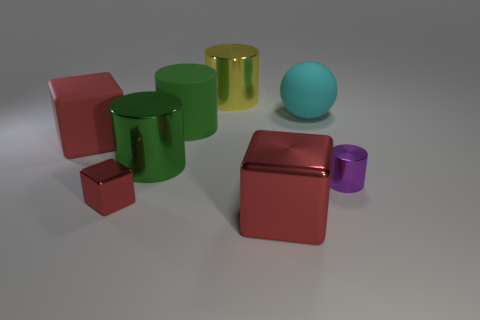Do the red object on the right side of the yellow metallic object and the big red rubber thing have the same shape?
Your answer should be very brief. Yes. Does the purple metal object have the same shape as the cyan object?
Provide a succinct answer. No. Is there another small red object that has the same shape as the red rubber object?
Offer a very short reply. Yes. The large green object behind the block that is behind the small metallic cylinder is what shape?
Ensure brevity in your answer.  Cylinder. There is a tiny thing on the left side of the large cyan sphere; what color is it?
Your response must be concise. Red. The purple cylinder that is the same material as the big yellow cylinder is what size?
Offer a terse response. Small. What size is the purple metal thing that is the same shape as the large yellow object?
Provide a short and direct response. Small. Are there any small metal cylinders?
Provide a succinct answer. Yes. What number of things are either purple metallic cylinders to the right of the big rubber block or cylinders?
Offer a very short reply. 4. There is a yellow cylinder that is the same size as the cyan matte object; what material is it?
Your answer should be compact. Metal. 